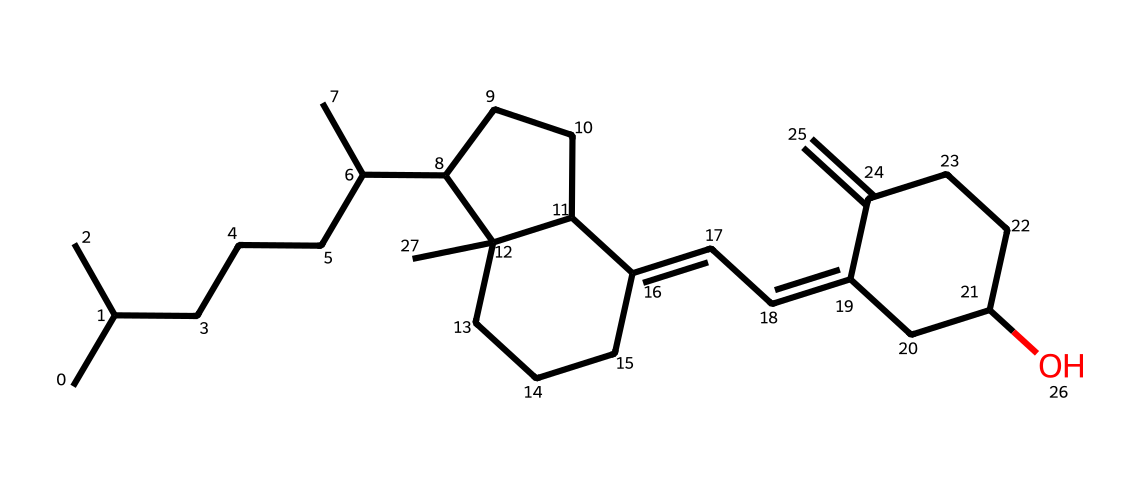What is the molecular formula for this chemical? By examining the structure, we count the number of carbon (C), hydrogen (H), and oxygen (O) atoms it contains. The chemical is a derivative of vitamin D, which typically has a complex structure. In this case, there are 30 carbon atoms, 50 hydrogen atoms, and 1 oxygen atom, leading us to the formula C30H50O.
Answer: C30H50O How many rings are present in this structure? Looking at the chemical structure, you can identify the cyclic components. In this case, we can see two distinct rings upon analysis of the structure; they are formed of carbon atoms.
Answer: 2 What type of vitamin is represented by this structure? The given SMILES corresponds to vitamin D, which is categorized as a fat-soluble vitamin. This categorization is derived from its structure which possesses a hydrocarbon backbone conducive to lipid solubility.
Answer: vitamin D How does UV light impact this compound? Vitamin D synthesis is significantly stimulated by UV light; this compound's structure incorporates UV-reactive properties that allow it to absorb UV radiation. The reaction leads to the production of a biologically active form essential for calcium absorption in the body.
Answer: stimulates synthesis What is the main functional group in this structure? Analyzing the entire chemical structure, we find that the hydroxyl (-OH) group is present, indicating the presence of alcohol functionality. By examining the attachments, we can confirm this is the dominant functional group.
Answer: hydroxyl group Does this molecule contain any unsaturated bonds? By examining the carbon-carbon connections visually in the structure, we can identify double bonds that are characteristic of unsaturated hydrocarbons, confirming the presence of two unsaturated bonds in the compound.
Answer: yes How many double bonds does this molecule have? Analyzing the structure closely for any double bonds, we can find two specified locations where double bonds are present in the carbon chain, determining the total count to be two.
Answer: 2 